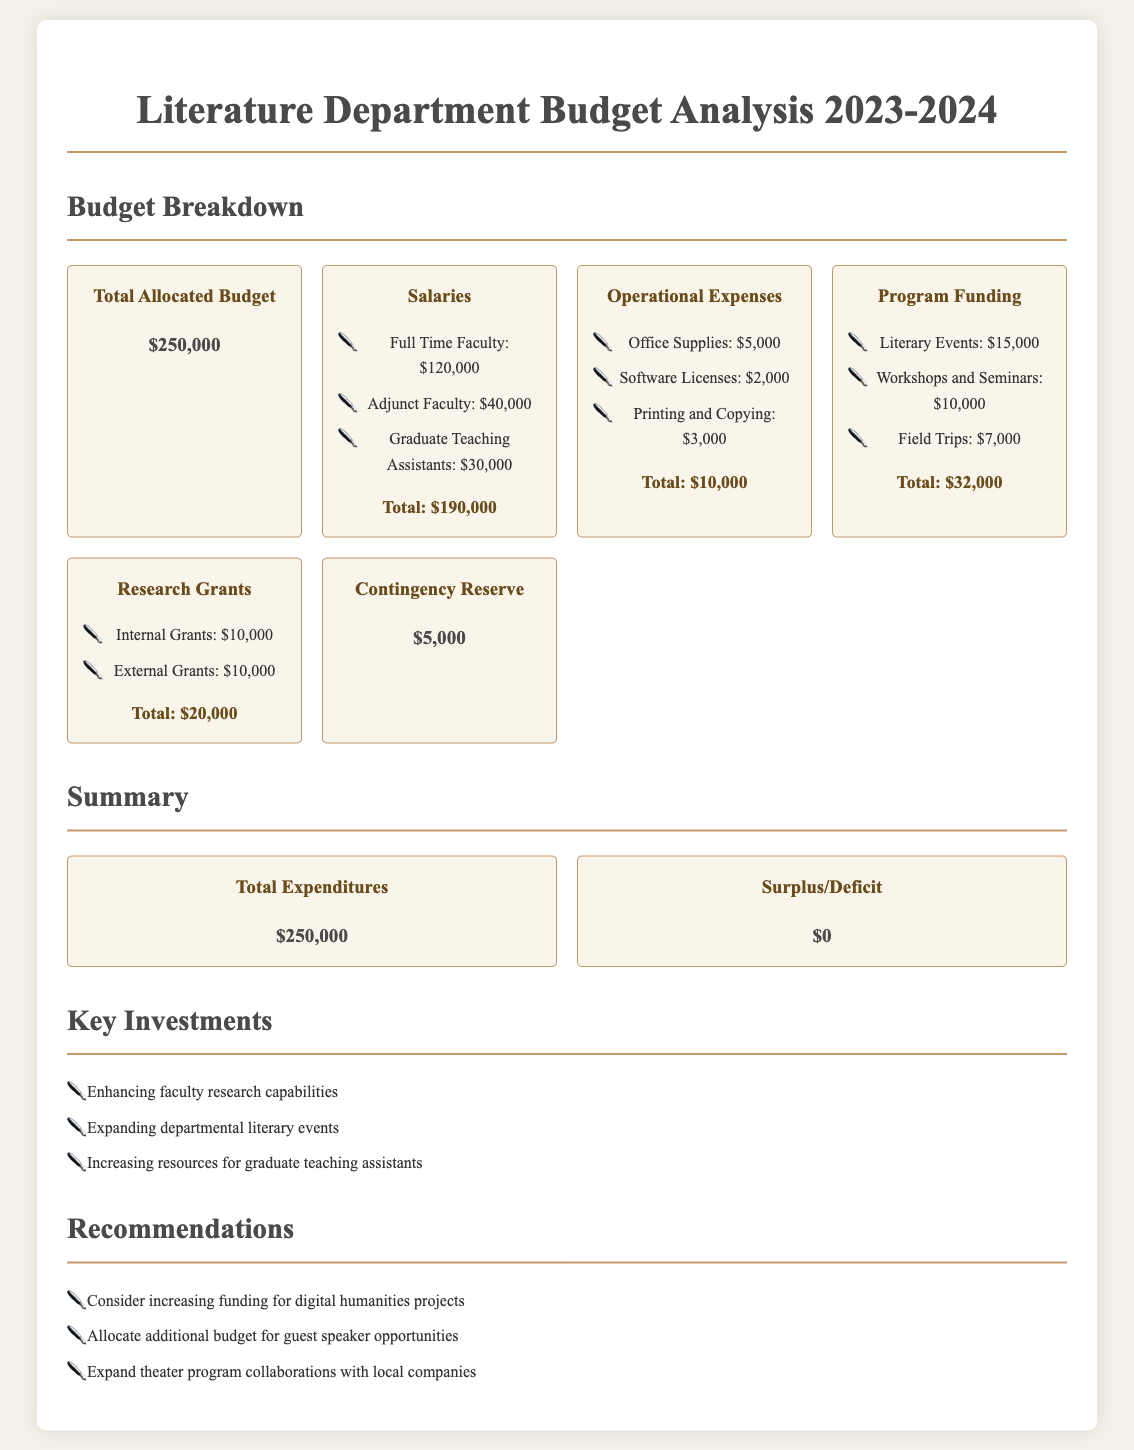What is the total allocated budget? The total allocated budget is stated clearly in the document as the main budget figure.
Answer: $250,000 How much is allocated for full-time faculty salaries? The document specifies the salary allocation for full-time faculty, which is clearly detailed among the faculty salaries.
Answer: $120,000 What is the total for operational expenses? The total for operational expenses is calculated from individual expense items listed under that category.
Answer: $10,000 How much funding is allocated for workshops and seminars? The amount allocated for workshops and seminars is indicated under the program funding section.
Answer: $10,000 What is the surplus or deficit for the year? The document includes a summary section that outlines the financial outcome of the budget.
Answer: $0 What percentage of the total budget is used for salaries? This requires evaluating the total allocated budget against the total salaries to determine the percentage used.
Answer: 76% What is one key investment highlighted in the document? The document lists key investments aimed at improving the department, with specific examples provided.
Answer: Enhancing faculty research capabilities What is the contingency reserve amount? The contingency reserve is specified and presents a reserved financial amount for uncertainties.
Answer: $5,000 What recommendation is made regarding digital humanities projects? A specific recommendation is identified in the recommendations section, relating to funding priorities.
Answer: Consider increasing funding for digital humanities projects 